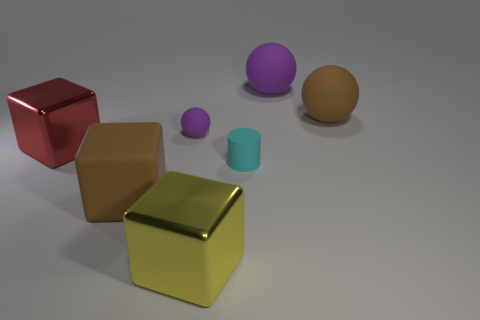There is a brown ball that is the same size as the yellow metal thing; what material is it? Based on the image, the brown ball appears to have a matt surface similar to that of polished wood. While it's not possible to definitively determine the material without additional context or information, the ball's color and texture suggest that it could be made of wood or a wood-like material. 